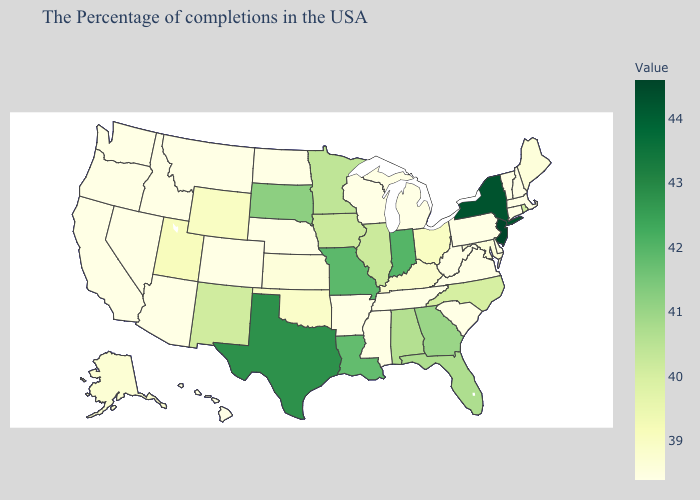Is the legend a continuous bar?
Concise answer only. Yes. Does Rhode Island have the highest value in the USA?
Keep it brief. No. Among the states that border Virginia , does North Carolina have the lowest value?
Quick response, please. No. Which states have the lowest value in the USA?
Short answer required. Massachusetts, New Hampshire, Vermont, Connecticut, Delaware, Pennsylvania, Virginia, South Carolina, West Virginia, Michigan, Tennessee, Wisconsin, Mississippi, Arkansas, Nebraska, North Dakota, Colorado, Montana, Arizona, Idaho, Nevada, California, Washington, Oregon, Hawaii. Among the states that border Maine , which have the highest value?
Concise answer only. New Hampshire. Does Minnesota have the lowest value in the USA?
Quick response, please. No. Does the map have missing data?
Be succinct. No. 